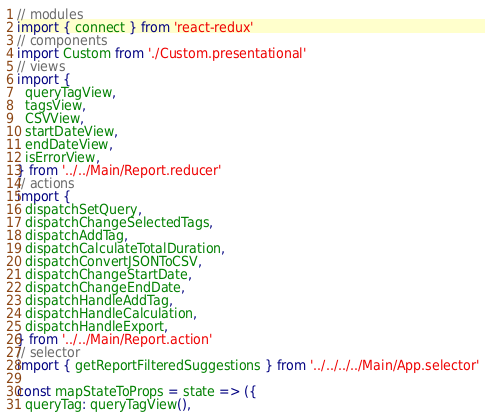Convert code to text. <code><loc_0><loc_0><loc_500><loc_500><_JavaScript_>// modules
import { connect } from 'react-redux'
// components
import Custom from './Custom.presentational'
// views
import {
  queryTagView,
  tagsView,
  CSVView,
  startDateView,
  endDateView,
  isErrorView,
} from '../../Main/Report.reducer'
// actions
import {
  dispatchSetQuery,
  dispatchChangeSelectedTags,
  dispatchAddTag,
  dispatchCalculateTotalDuration,
  dispatchConvertJSONToCSV,
  dispatchChangeStartDate,
  dispatchChangeEndDate,
  dispatchHandleAddTag,
  dispatchHandleCalculation,
  dispatchHandleExport,
} from '../../Main/Report.action'
// selector
import { getReportFilteredSuggestions } from '../../../../Main/App.selector'

const mapStateToProps = state => ({
  queryTag: queryTagView(),</code> 